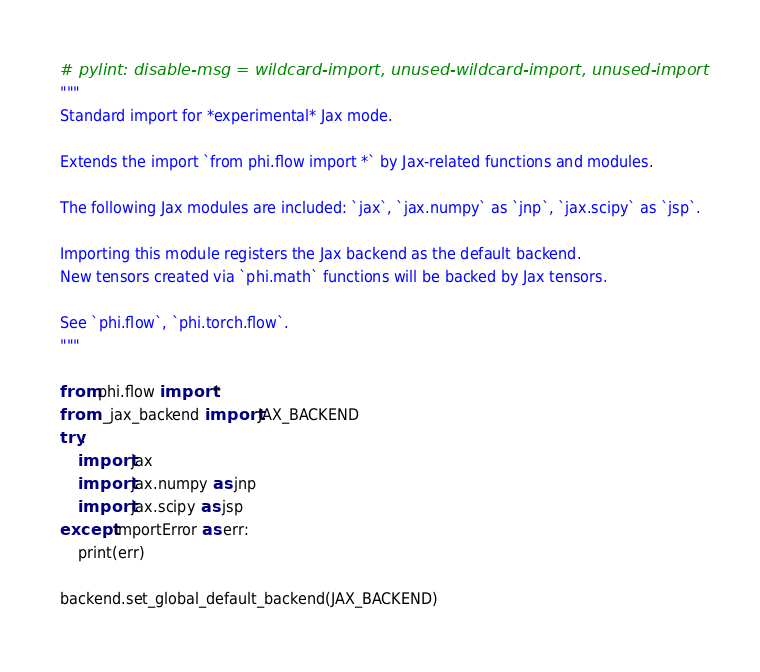<code> <loc_0><loc_0><loc_500><loc_500><_Python_># pylint: disable-msg = wildcard-import, unused-wildcard-import, unused-import
"""
Standard import for *experimental* Jax mode.

Extends the import `from phi.flow import *` by Jax-related functions and modules.

The following Jax modules are included: `jax`, `jax.numpy` as `jnp`, `jax.scipy` as `jsp`.

Importing this module registers the Jax backend as the default backend.
New tensors created via `phi.math` functions will be backed by Jax tensors.

See `phi.flow`, `phi.torch.flow`.
"""

from phi.flow import *
from ._jax_backend import JAX_BACKEND
try:
    import jax
    import jax.numpy as jnp
    import jax.scipy as jsp
except ImportError as err:
    print(err)

backend.set_global_default_backend(JAX_BACKEND)
</code> 